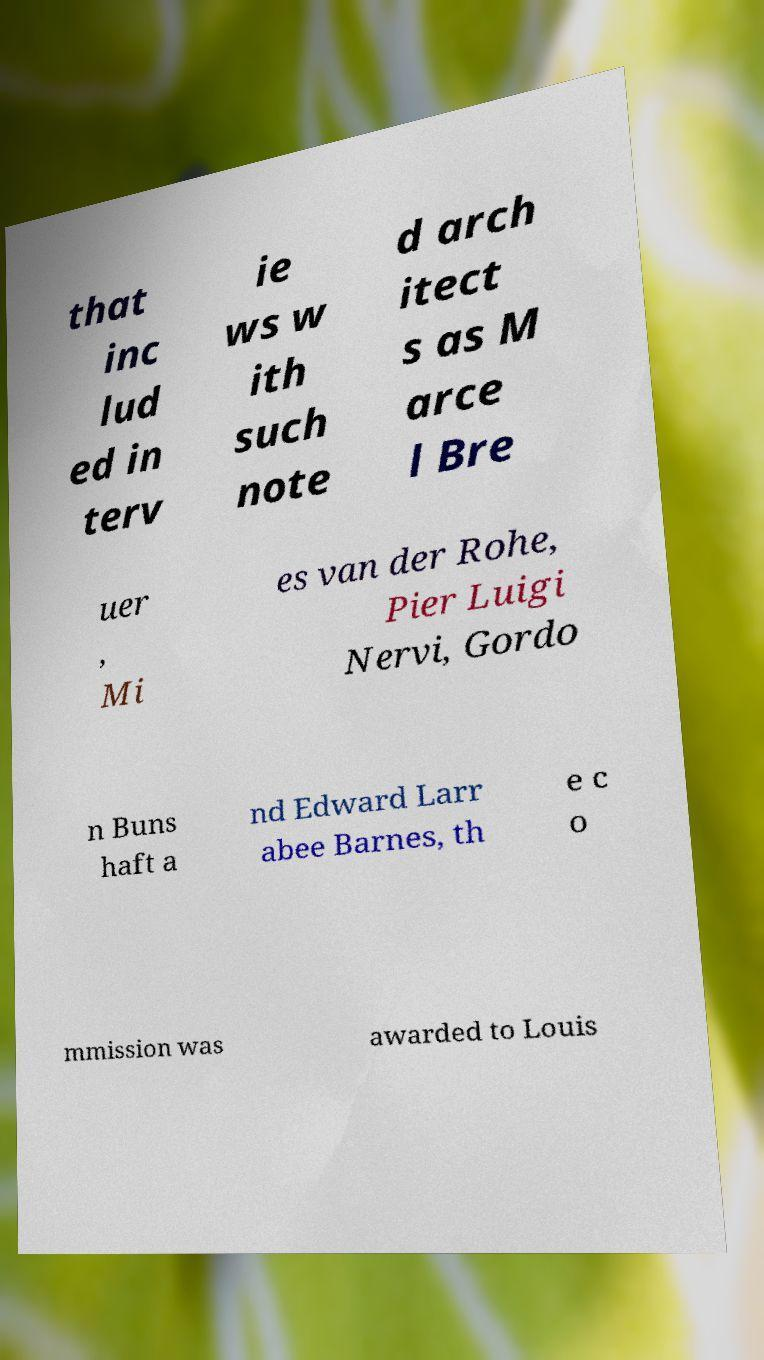Please read and relay the text visible in this image. What does it say? that inc lud ed in terv ie ws w ith such note d arch itect s as M arce l Bre uer , Mi es van der Rohe, Pier Luigi Nervi, Gordo n Buns haft a nd Edward Larr abee Barnes, th e c o mmission was awarded to Louis 